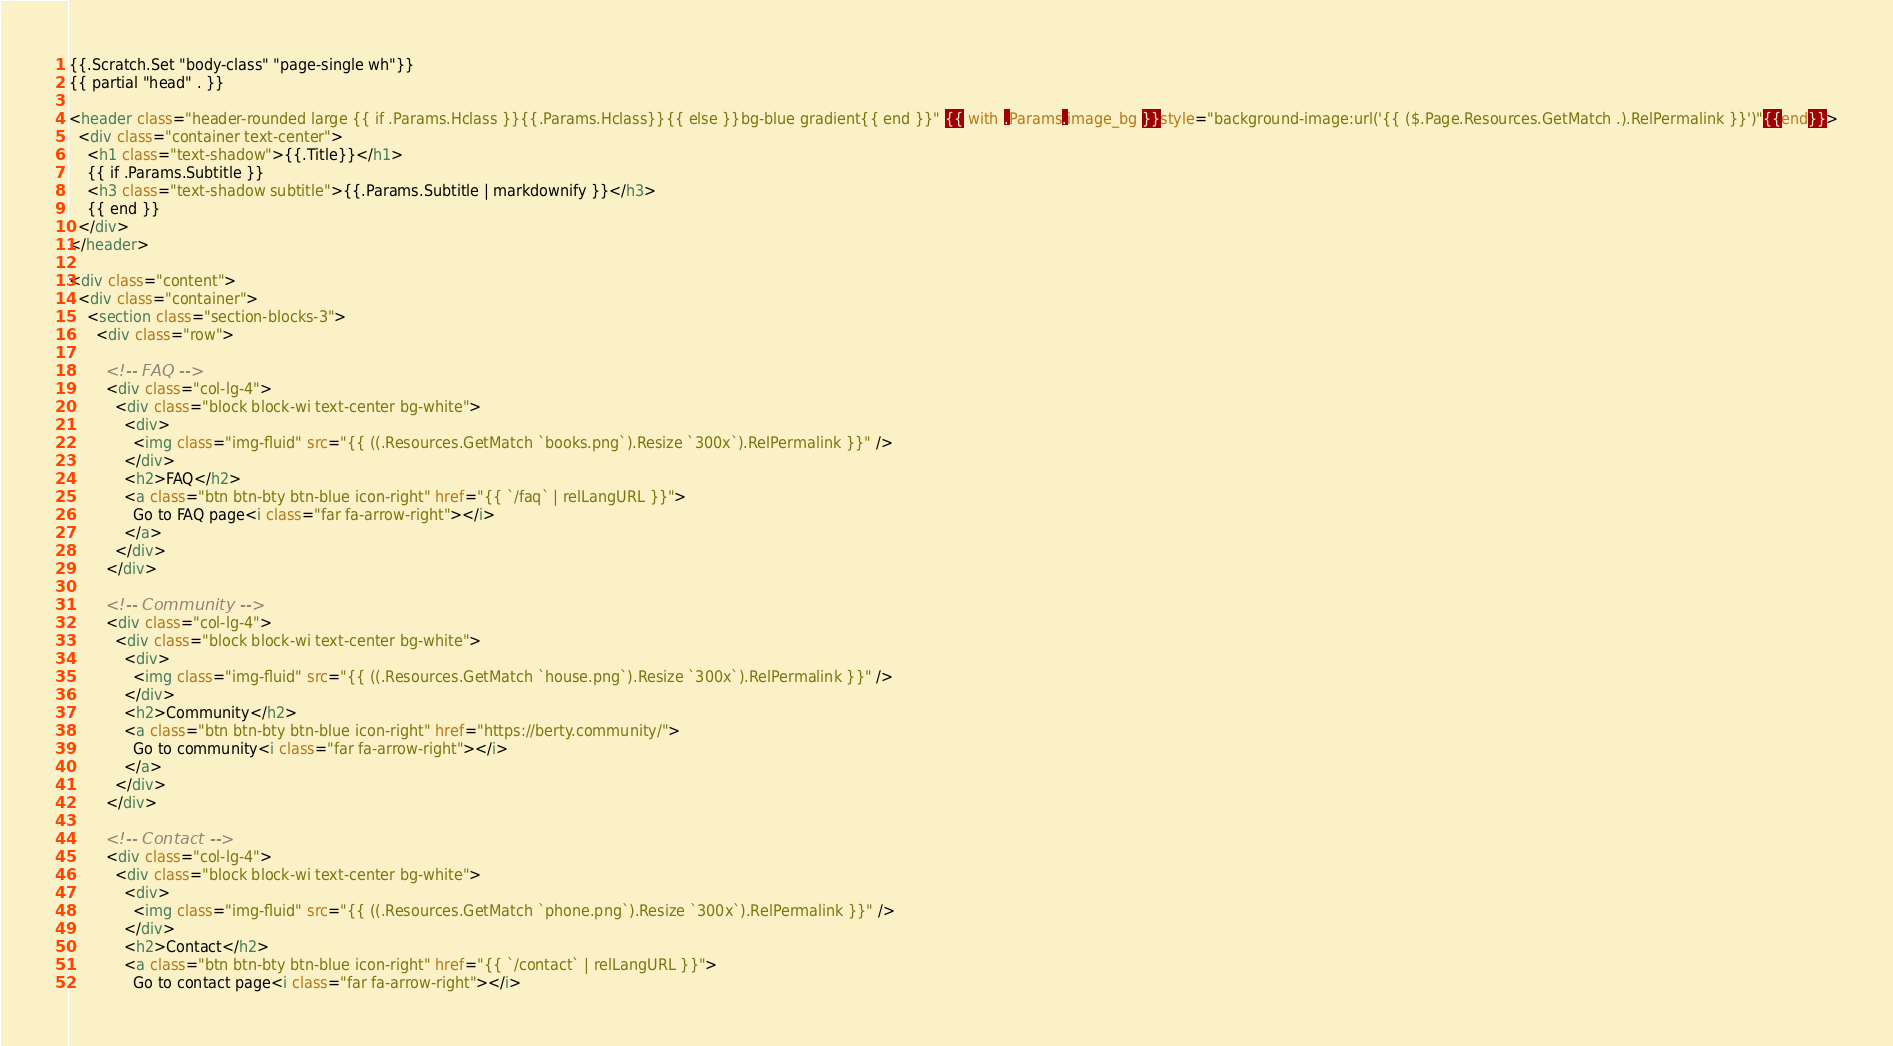Convert code to text. <code><loc_0><loc_0><loc_500><loc_500><_HTML_>{{.Scratch.Set "body-class" "page-single wh"}}
{{ partial "head" . }}

<header class="header-rounded large {{ if .Params.Hclass }}{{.Params.Hclass}}{{ else }}bg-blue gradient{{ end }}" {{ with .Params.image_bg }}style="background-image:url('{{ ($.Page.Resources.GetMatch .).RelPermalink }}')"{{end}}>
  <div class="container text-center">
    <h1 class="text-shadow">{{.Title}}</h1>
    {{ if .Params.Subtitle }}
    <h3 class="text-shadow subtitle">{{.Params.Subtitle | markdownify }}</h3>
    {{ end }}
  </div>
</header>

<div class="content">
  <div class="container">
    <section class="section-blocks-3">
      <div class="row">

        <!-- FAQ -->
        <div class="col-lg-4">
          <div class="block block-wi text-center bg-white">
            <div>
              <img class="img-fluid" src="{{ ((.Resources.GetMatch `books.png`).Resize `300x`).RelPermalink }}" />
            </div>
            <h2>FAQ</h2>
            <a class="btn btn-bty btn-blue icon-right" href="{{ `/faq` | relLangURL }}">
              Go to FAQ page<i class="far fa-arrow-right"></i>
            </a>
          </div>
        </div>

        <!-- Community -->
        <div class="col-lg-4">
          <div class="block block-wi text-center bg-white">
            <div>
              <img class="img-fluid" src="{{ ((.Resources.GetMatch `house.png`).Resize `300x`).RelPermalink }}" />
            </div>
            <h2>Community</h2>
            <a class="btn btn-bty btn-blue icon-right" href="https://berty.community/">
              Go to community<i class="far fa-arrow-right"></i>
            </a>
          </div>
        </div>

        <!-- Contact -->
        <div class="col-lg-4">
          <div class="block block-wi text-center bg-white">
            <div>
              <img class="img-fluid" src="{{ ((.Resources.GetMatch `phone.png`).Resize `300x`).RelPermalink }}" />
            </div>
            <h2>Contact</h2>
            <a class="btn btn-bty btn-blue icon-right" href="{{ `/contact` | relLangURL }}">
              Go to contact page<i class="far fa-arrow-right"></i></code> 